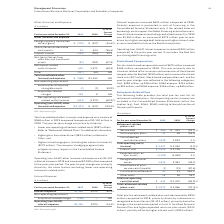According to International Business Machines's financial document, What caused the total consolidated other (income) and expenses to decrease? The year-to-year change was primarily driven by: • Lower non-operating retirement-related costs ($957 million). Refer to “Retirement-Related Plans” for additional information. • Higher gains from divestitures ($833 million) reflected in Other; and • Higher net exchange gains (including derivative instruments) ($272 million). The company’s hedging programs help mitigate currency impacts in the Consolidated Income Statement.. The document states: "019 compared to expense of $1,152 million in 2018. The year-to-year change was primarily driven by: • Lower non-operating retirement-related costs ($9..." Also, What caused the Operating (non-GAAP) other (income) and expense to increase? The year-to-year change was primarily driven by the same factors excluding lower non-operating retirement-related costs.. The document states: "$1,010 million compared to the prior-year period. The year-to-year change was primarily driven by the same factors excluding lower non-operating retir..." Also, What was the total Operating (non-GAAP) other (income) and expense in 2019? According to the financial document, $(1,431) (in millions). The relevant text states: "Operating (non-GAAP) other (income) and expense $(1,431) $ (422) 239.4%..." Also, can you calculate: What was the increase / (decrease) in the Foreign currency transaction losses/(gains) from 2018 to 2019? Based on the calculation: -279 - (-427), the result is 148 (in millions). This is based on the information: "Foreign currency transaction losses/(gains) $ (279) $ (427) (34.6)% gn currency transaction losses/(gains) $ (279) $ (427) (34.6)%..." The key data points involved are: 279, 427. Also, can you calculate: What is the increase / (decrease) in the interest income from 2018 to 2019? Based on the calculation: -349 - (-264), the result is -85 (in millions). This is based on the information: "Interest income (349) (264) 32.2 Interest income (349) (264) 32.2..." The key data points involved are: 264, 349. Also, can you calculate: What is the average Acquisition-related charges? To answer this question, I need to perform calculations using the financial data. The calculation is: (154 + 0) / 2, which equals 77 (in millions). This is based on the information: "Acquisition-related charges 154 0 NM Acquisition-related charges 154 0 NM..." The key data points involved are: 0, 154. 